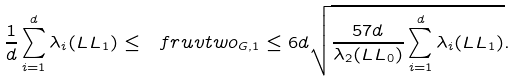<formula> <loc_0><loc_0><loc_500><loc_500>\frac { 1 } { d } \sum _ { i = 1 } ^ { d } \lambda _ { i } ( \L L L _ { 1 } ) \leq \ f r u v t w o _ { G , 1 } \leq 6 d \sqrt { \frac { 5 7 d } { \lambda _ { 2 } ( \L L L _ { 0 } ) } \sum _ { i = 1 } ^ { d } \lambda _ { i } ( \L L L _ { 1 } ) } .</formula> 